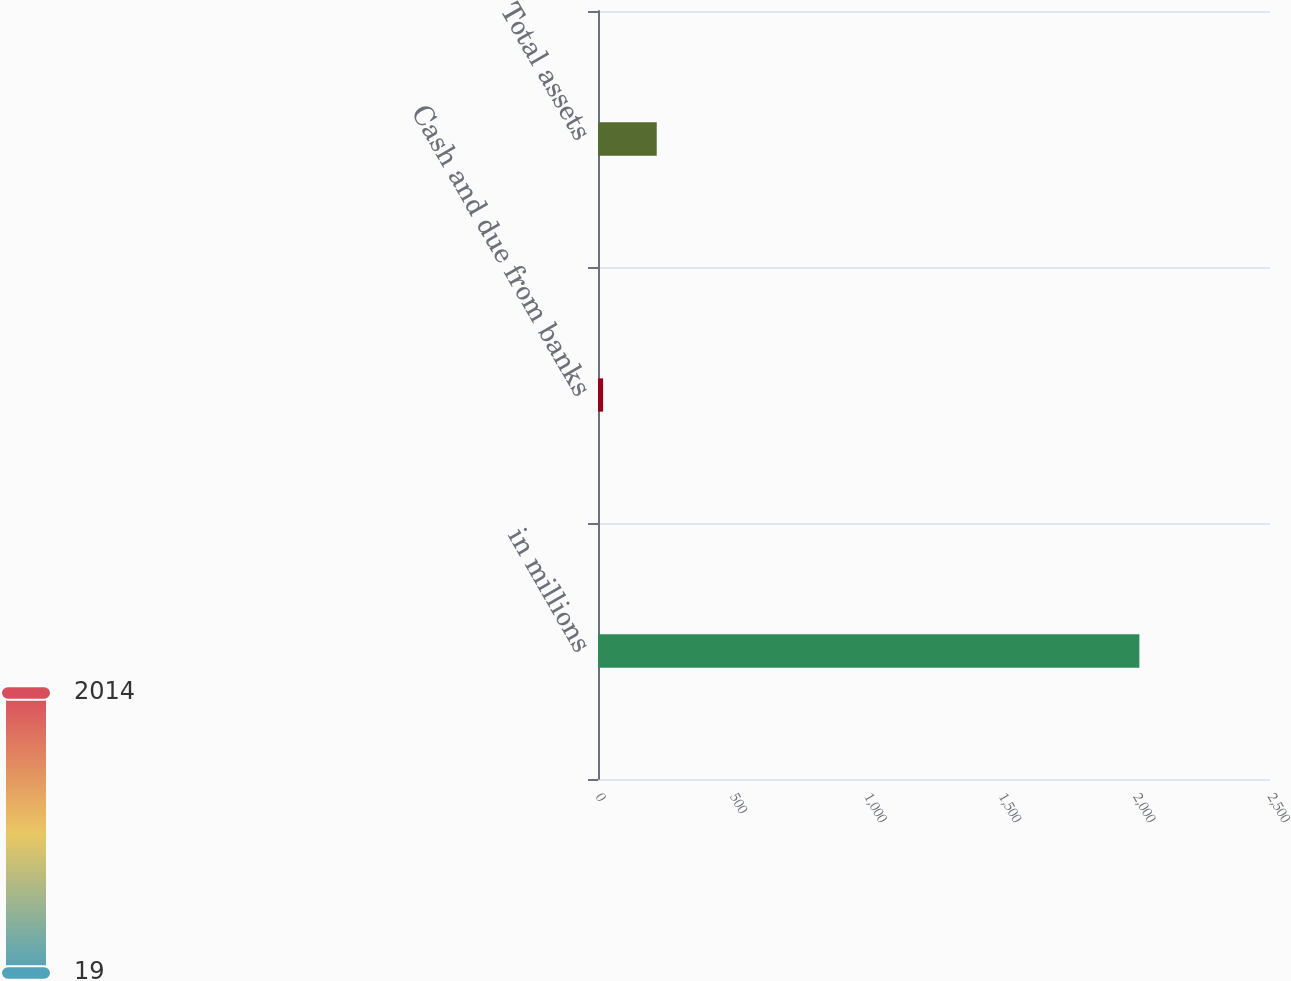<chart> <loc_0><loc_0><loc_500><loc_500><bar_chart><fcel>in millions<fcel>Cash and due from banks<fcel>Total assets<nl><fcel>2014<fcel>19<fcel>218.5<nl></chart> 